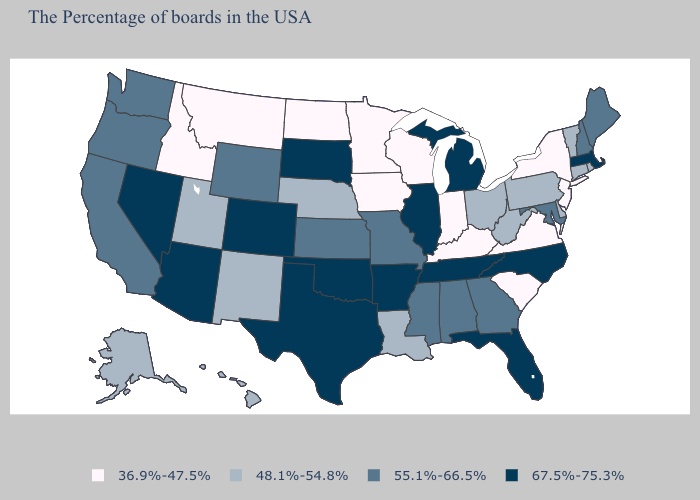What is the value of Iowa?
Concise answer only. 36.9%-47.5%. What is the highest value in states that border Arkansas?
Short answer required. 67.5%-75.3%. How many symbols are there in the legend?
Answer briefly. 4. Name the states that have a value in the range 55.1%-66.5%?
Write a very short answer. Maine, New Hampshire, Maryland, Georgia, Alabama, Mississippi, Missouri, Kansas, Wyoming, California, Washington, Oregon. What is the value of Maine?
Short answer required. 55.1%-66.5%. Does the first symbol in the legend represent the smallest category?
Be succinct. Yes. Among the states that border Montana , which have the highest value?
Be succinct. South Dakota. Name the states that have a value in the range 48.1%-54.8%?
Be succinct. Rhode Island, Vermont, Connecticut, Delaware, Pennsylvania, West Virginia, Ohio, Louisiana, Nebraska, New Mexico, Utah, Alaska, Hawaii. Name the states that have a value in the range 36.9%-47.5%?
Short answer required. New York, New Jersey, Virginia, South Carolina, Kentucky, Indiana, Wisconsin, Minnesota, Iowa, North Dakota, Montana, Idaho. What is the value of Missouri?
Quick response, please. 55.1%-66.5%. What is the value of Wyoming?
Answer briefly. 55.1%-66.5%. Does Michigan have the same value as Iowa?
Concise answer only. No. Which states hav the highest value in the South?
Short answer required. North Carolina, Florida, Tennessee, Arkansas, Oklahoma, Texas. Does Kansas have the lowest value in the MidWest?
Keep it brief. No. Does Idaho have a lower value than Alabama?
Answer briefly. Yes. 